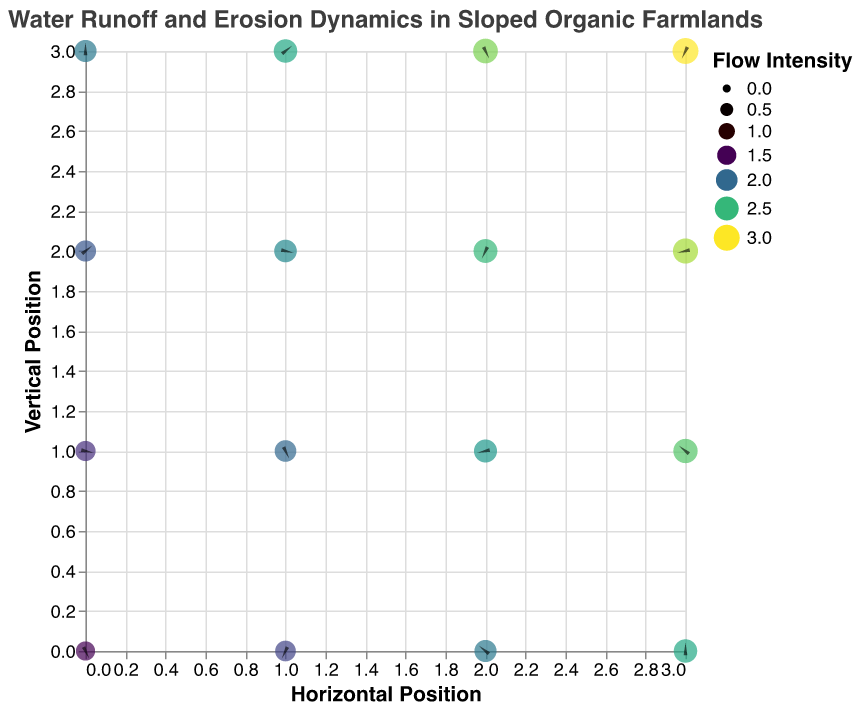What is the title of the figure? The title of the figure is displayed at the top and it reads "Water Runoff and Erosion Dynamics in Sloped Organic Farmlands".
Answer: Water Runoff and Erosion Dynamics in Sloped Organic Farmlands What do the colors in the figure represent? The colors in the figure represent the flow intensity, with the legend indicating that a color scale (likely viridis) is used to differentiate intensity levels.
Answer: Flow intensity How many data points are there in the plot? By observing the figure, we can count the circles or arrows representing different data points. There are 4 horizontal positions (0 to 3) and 4 vertical positions (0 to 3), amounting to a total of 16 data points.
Answer: 16 What direction is the water flow at position (2,0)? The quiver plot arrows indicate the direction of water flow. At position (2,0), the arrow is pointing up and slightly to the right, indicating U = 0.1 and V = 0.5.
Answer: Up and slightly to the right Which position has the highest flow intensity? By looking at the size and color of the circles, the position with the largest and darkest (most intense in the viridis color scheme) circle represents the highest flow intensity. The maximum intensity in the data is 3.0, which corresponds to position (3,3).
Answer: (3,3) What is the general trend of water flow intensity as we move from position (0,0) to (3,3)? Observing the color and size of the circles from (0,0) to (3,3), there is an increasing trend in both attributes, indicating an increase in water flow intensity up to the highest value of 3.0.
Answer: Increasing trend Compare the water flow direction at (0,1) and (3,1). Which one has a more significant horizontal component? The water flow direction at (0,1) has U = -0.3 (left) and at (3,1) has U = 0.1 (right). The magnitude of the horizontal component at (0,1) is greater than that at (3,1).
Answer: (0,1) Which position has the most vertical water flow? The vertical component V of the water flow is highest at (3,3) where V = 0.9. The arrows indicate the direction, and the length relates to the magnitude, confirming (3,3) has the most vertical flow.
Answer: (3,3) How does the horizontal component of water flow change along the Y-axis at X=1? Looking at the data points at X=1 for different Y values (Y=0 to Y=3), U changes from -0.1 to -0.4. This shows the horizontal component becomes more negative (more leftward) as Y increases.
Answer: Becomes more negative 